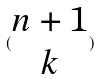Convert formula to latex. <formula><loc_0><loc_0><loc_500><loc_500>( \begin{matrix} n + 1 \\ k \end{matrix} )</formula> 